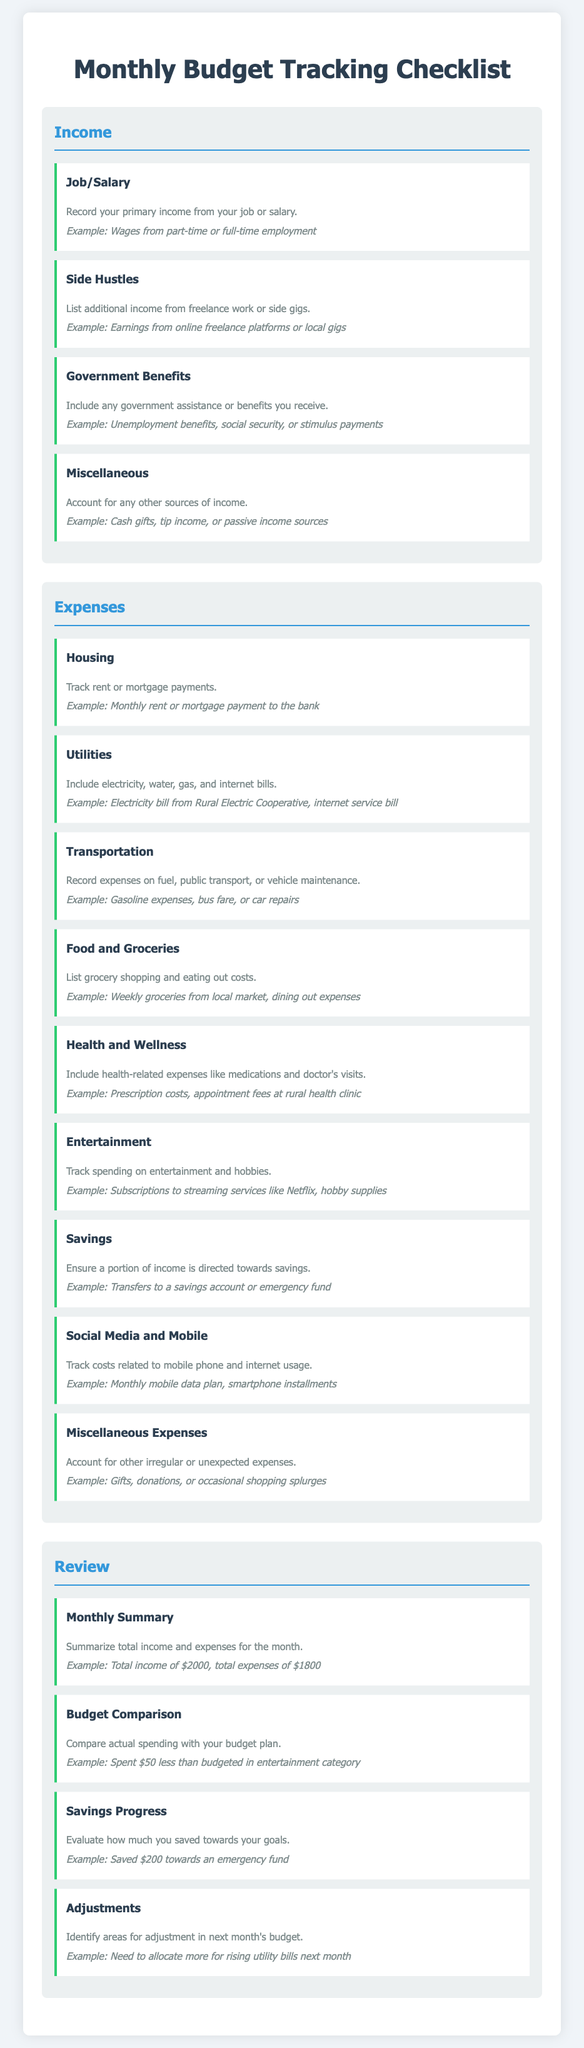What are the four income sources listed? The income sources include Job/Salary, Side Hustles, Government Benefits, and Miscellaneous.
Answer: Job/Salary, Side Hustles, Government Benefits, Miscellaneous How many expense categories are there? The expense categories presented in the document are nine in total.
Answer: Nine What example is given for Housing expenses? The example for Housing expenses mentioned is the monthly rent or mortgage payment to the bank.
Answer: Monthly rent or mortgage payment to the bank What does the Monthly Summary section require? The Monthly Summary section requires summarizing total income and expenses for the month.
Answer: Summarizing total income and expenses Which expense category includes prescription costs? The Health and Wellness category includes health-related expenses like medications.
Answer: Health and Wellness What is one adjustment suggested for the next month's budget? The example suggests allocating more for rising utility bills next month.
Answer: Allocating more for rising utility bills What type of income does the term 'Side Hustles' refer to? Side Hustles refer to additional income from freelance work or side gigs.
Answer: Additional income from freelance work or side gigs What should a budget comparison reveal? A budget comparison should reveal how actual spending compares with the budget plan.
Answer: How actual spending compares with the budget plan What should you account for in Miscellaneous Expenses? In Miscellaneous Expenses, you should account for other irregular or unexpected expenses.
Answer: Other irregular or unexpected expenses 